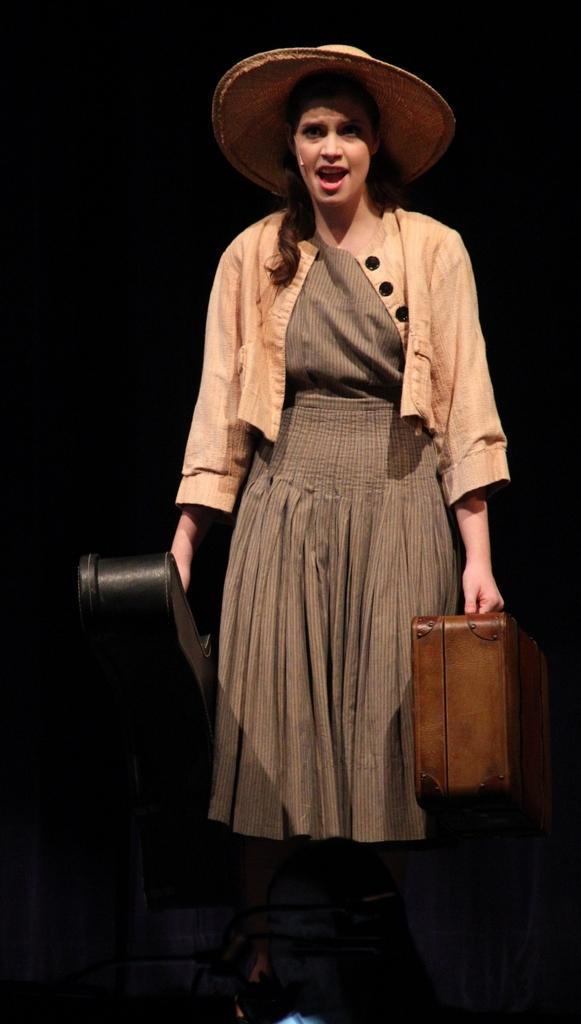Can you describe this image briefly? A woman wearing a top and a skirt also a hat is singing and holding a suitcase and violin bag. 